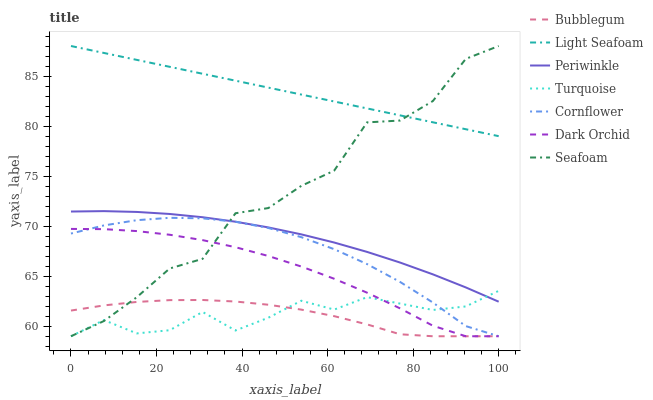Does Bubblegum have the minimum area under the curve?
Answer yes or no. Yes. Does Light Seafoam have the maximum area under the curve?
Answer yes or no. Yes. Does Turquoise have the minimum area under the curve?
Answer yes or no. No. Does Turquoise have the maximum area under the curve?
Answer yes or no. No. Is Light Seafoam the smoothest?
Answer yes or no. Yes. Is Seafoam the roughest?
Answer yes or no. Yes. Is Turquoise the smoothest?
Answer yes or no. No. Is Turquoise the roughest?
Answer yes or no. No. Does Cornflower have the lowest value?
Answer yes or no. Yes. Does Periwinkle have the lowest value?
Answer yes or no. No. Does Light Seafoam have the highest value?
Answer yes or no. Yes. Does Turquoise have the highest value?
Answer yes or no. No. Is Periwinkle less than Light Seafoam?
Answer yes or no. Yes. Is Periwinkle greater than Dark Orchid?
Answer yes or no. Yes. Does Dark Orchid intersect Seafoam?
Answer yes or no. Yes. Is Dark Orchid less than Seafoam?
Answer yes or no. No. Is Dark Orchid greater than Seafoam?
Answer yes or no. No. Does Periwinkle intersect Light Seafoam?
Answer yes or no. No. 